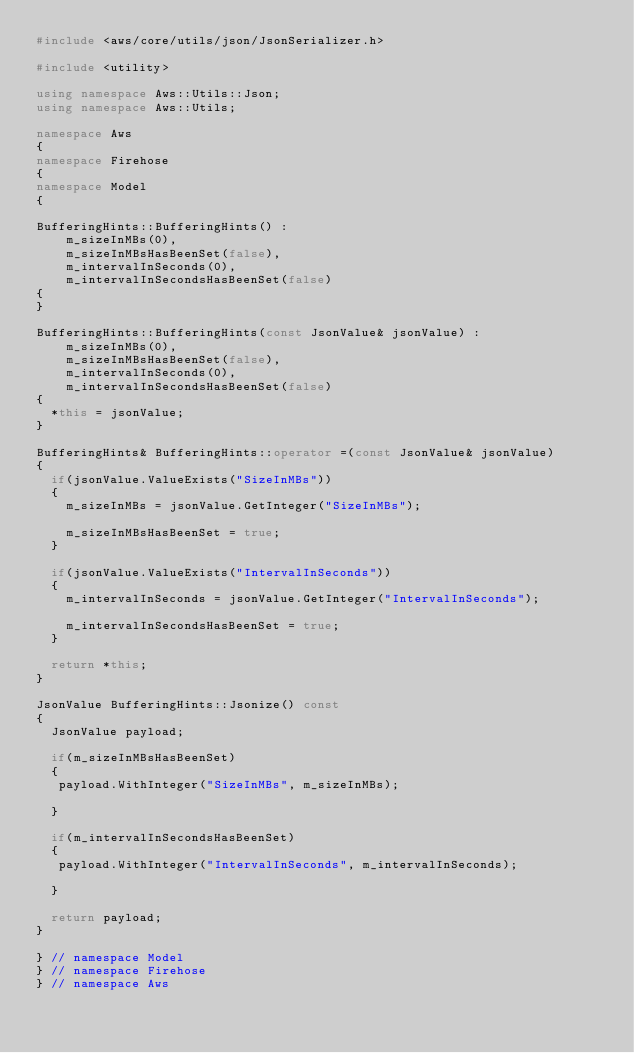<code> <loc_0><loc_0><loc_500><loc_500><_C++_>#include <aws/core/utils/json/JsonSerializer.h>

#include <utility>

using namespace Aws::Utils::Json;
using namespace Aws::Utils;

namespace Aws
{
namespace Firehose
{
namespace Model
{

BufferingHints::BufferingHints() : 
    m_sizeInMBs(0),
    m_sizeInMBsHasBeenSet(false),
    m_intervalInSeconds(0),
    m_intervalInSecondsHasBeenSet(false)
{
}

BufferingHints::BufferingHints(const JsonValue& jsonValue) : 
    m_sizeInMBs(0),
    m_sizeInMBsHasBeenSet(false),
    m_intervalInSeconds(0),
    m_intervalInSecondsHasBeenSet(false)
{
  *this = jsonValue;
}

BufferingHints& BufferingHints::operator =(const JsonValue& jsonValue)
{
  if(jsonValue.ValueExists("SizeInMBs"))
  {
    m_sizeInMBs = jsonValue.GetInteger("SizeInMBs");

    m_sizeInMBsHasBeenSet = true;
  }

  if(jsonValue.ValueExists("IntervalInSeconds"))
  {
    m_intervalInSeconds = jsonValue.GetInteger("IntervalInSeconds");

    m_intervalInSecondsHasBeenSet = true;
  }

  return *this;
}

JsonValue BufferingHints::Jsonize() const
{
  JsonValue payload;

  if(m_sizeInMBsHasBeenSet)
  {
   payload.WithInteger("SizeInMBs", m_sizeInMBs);

  }

  if(m_intervalInSecondsHasBeenSet)
  {
   payload.WithInteger("IntervalInSeconds", m_intervalInSeconds);

  }

  return payload;
}

} // namespace Model
} // namespace Firehose
} // namespace Aws</code> 